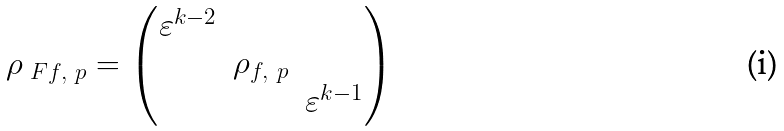<formula> <loc_0><loc_0><loc_500><loc_500>\rho _ { \ F f , \ p } = \begin{pmatrix} \varepsilon ^ { k - 2 } & & \\ & \rho _ { f , \ p } & \\ & & \varepsilon ^ { k - 1 } \end{pmatrix}</formula> 